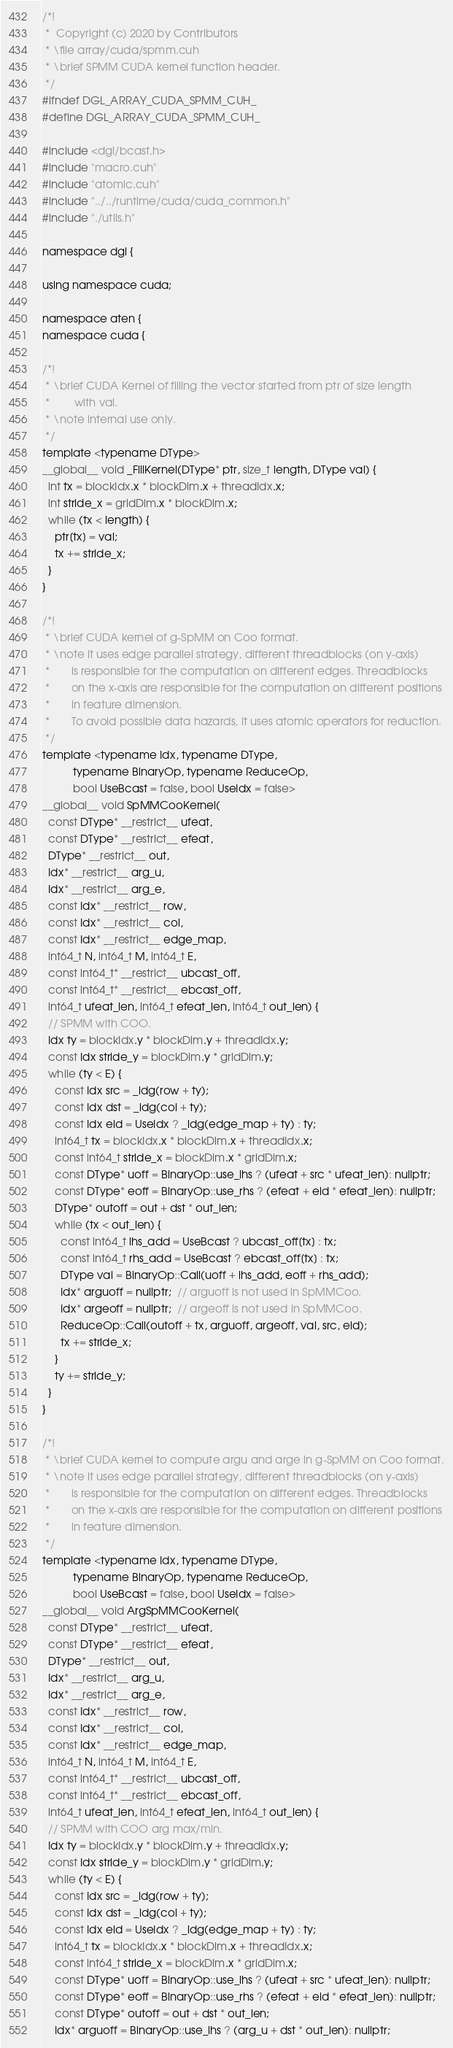<code> <loc_0><loc_0><loc_500><loc_500><_Cuda_>/*!
 *  Copyright (c) 2020 by Contributors
 * \file array/cuda/spmm.cuh
 * \brief SPMM CUDA kernel function header.
 */
#ifndef DGL_ARRAY_CUDA_SPMM_CUH_
#define DGL_ARRAY_CUDA_SPMM_CUH_

#include <dgl/bcast.h>
#include "macro.cuh"
#include "atomic.cuh"
#include "../../runtime/cuda/cuda_common.h"
#include "./utils.h"

namespace dgl {

using namespace cuda;

namespace aten {
namespace cuda {

/*! 
 * \brief CUDA Kernel of filling the vector started from ptr of size length
 *        with val.
 * \note internal use only.
 */
template <typename DType>
__global__ void _FillKernel(DType* ptr, size_t length, DType val) {
  int tx = blockIdx.x * blockDim.x + threadIdx.x;
  int stride_x = gridDim.x * blockDim.x;
  while (tx < length) {
    ptr[tx] = val;
    tx += stride_x;
  }
}

/*!
 * \brief CUDA kernel of g-SpMM on Coo format.
 * \note it uses edge parallel strategy, different threadblocks (on y-axis)
 *       is responsible for the computation on different edges. Threadblocks
 *       on the x-axis are responsible for the computation on different positions
 *       in feature dimension.
 *       To avoid possible data hazards, it uses atomic operators for reduction.
 */
template <typename Idx, typename DType,
          typename BinaryOp, typename ReduceOp,
          bool UseBcast = false, bool UseIdx = false>
__global__ void SpMMCooKernel(
  const DType* __restrict__ ufeat,
  const DType* __restrict__ efeat,
  DType* __restrict__ out,
  Idx* __restrict__ arg_u,
  Idx* __restrict__ arg_e,
  const Idx* __restrict__ row,
  const Idx* __restrict__ col,
  const Idx* __restrict__ edge_map,
  int64_t N, int64_t M, int64_t E,
  const int64_t* __restrict__ ubcast_off,
  const int64_t* __restrict__ ebcast_off,
  int64_t ufeat_len, int64_t efeat_len, int64_t out_len) {
  // SPMM with COO.
  Idx ty = blockIdx.y * blockDim.y + threadIdx.y;
  const Idx stride_y = blockDim.y * gridDim.y;
  while (ty < E) {
    const Idx src = _ldg(row + ty);
    const Idx dst = _ldg(col + ty);
    const Idx eid = UseIdx ? _ldg(edge_map + ty) : ty;
    int64_t tx = blockIdx.x * blockDim.x + threadIdx.x;
    const int64_t stride_x = blockDim.x * gridDim.x;
    const DType* uoff = BinaryOp::use_lhs ? (ufeat + src * ufeat_len): nullptr;
    const DType* eoff = BinaryOp::use_rhs ? (efeat + eid * efeat_len): nullptr;
    DType* outoff = out + dst * out_len;
    while (tx < out_len) {
      const int64_t lhs_add = UseBcast ? ubcast_off[tx] : tx;
      const int64_t rhs_add = UseBcast ? ebcast_off[tx] : tx;
      DType val = BinaryOp::Call(uoff + lhs_add, eoff + rhs_add);
      Idx* arguoff = nullptr;  // arguoff is not used in SpMMCoo.
      Idx* argeoff = nullptr;  // argeoff is not used in SpMMCoo.
      ReduceOp::Call(outoff + tx, arguoff, argeoff, val, src, eid);
      tx += stride_x;
    }
    ty += stride_y;
  }
}

/*!
 * \brief CUDA kernel to compute argu and arge in g-SpMM on Coo format.
 * \note it uses edge parallel strategy, different threadblocks (on y-axis)
 *       is responsible for the computation on different edges. Threadblocks
 *       on the x-axis are responsible for the computation on different positions
 *       in feature dimension.
 */
template <typename Idx, typename DType,
          typename BinaryOp, typename ReduceOp,
          bool UseBcast = false, bool UseIdx = false>
__global__ void ArgSpMMCooKernel(
  const DType* __restrict__ ufeat,
  const DType* __restrict__ efeat,
  DType* __restrict__ out,
  Idx* __restrict__ arg_u,
  Idx* __restrict__ arg_e,
  const Idx* __restrict__ row,
  const Idx* __restrict__ col,
  const Idx* __restrict__ edge_map,
  int64_t N, int64_t M, int64_t E,
  const int64_t* __restrict__ ubcast_off,
  const int64_t* __restrict__ ebcast_off,
  int64_t ufeat_len, int64_t efeat_len, int64_t out_len) {
  // SPMM with COO arg max/min.
  Idx ty = blockIdx.y * blockDim.y + threadIdx.y;
  const Idx stride_y = blockDim.y * gridDim.y;
  while (ty < E) {
    const Idx src = _ldg(row + ty);
    const Idx dst = _ldg(col + ty);
    const Idx eid = UseIdx ? _ldg(edge_map + ty) : ty;
    int64_t tx = blockIdx.x * blockDim.x + threadIdx.x;
    const int64_t stride_x = blockDim.x * gridDim.x;
    const DType* uoff = BinaryOp::use_lhs ? (ufeat + src * ufeat_len): nullptr;
    const DType* eoff = BinaryOp::use_rhs ? (efeat + eid * efeat_len): nullptr;
    const DType* outoff = out + dst * out_len;
    Idx* arguoff = BinaryOp::use_lhs ? (arg_u + dst * out_len): nullptr;</code> 